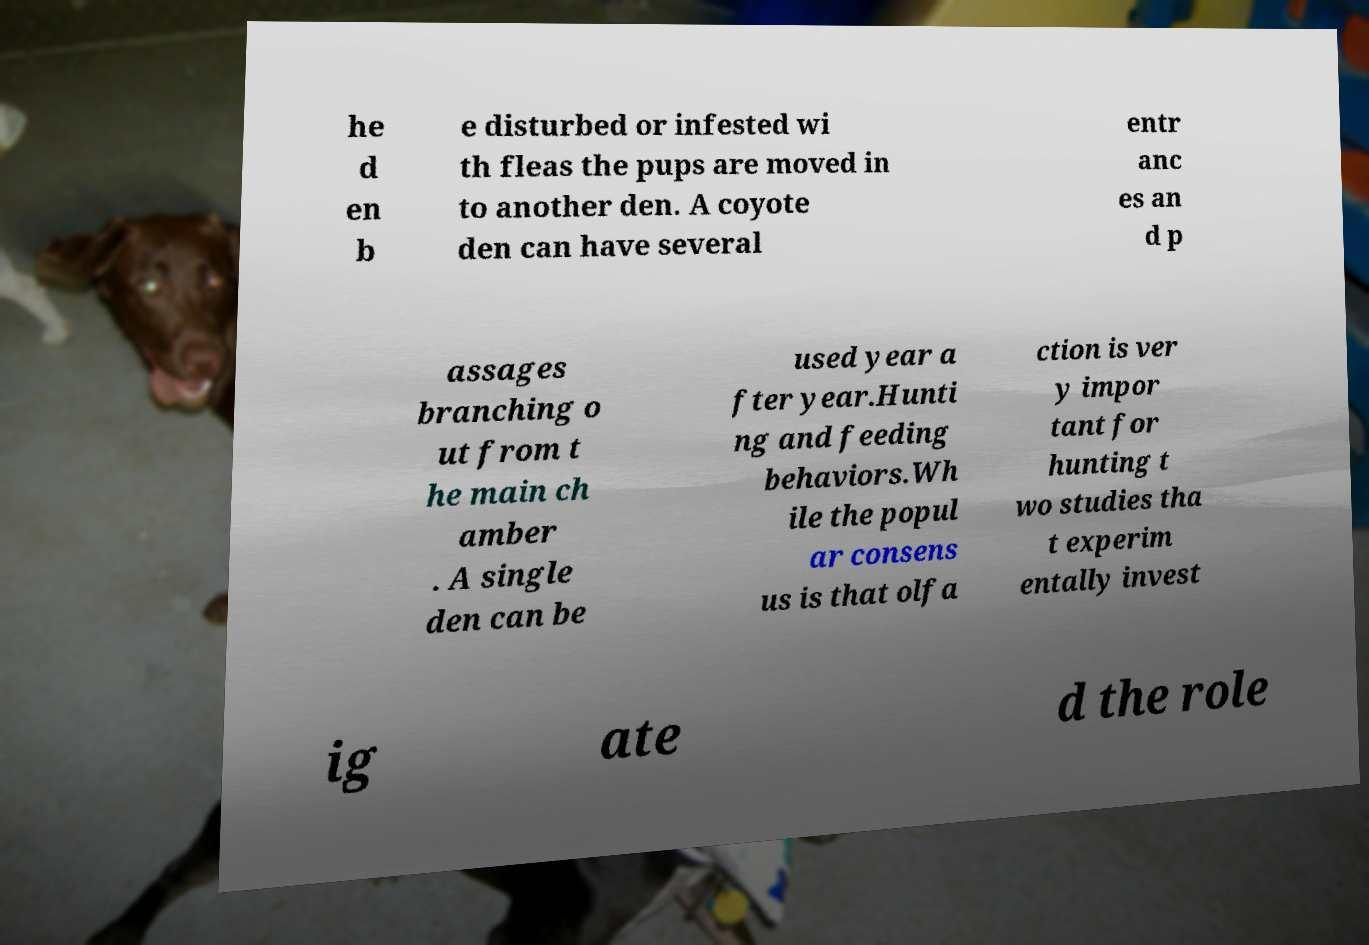Could you extract and type out the text from this image? he d en b e disturbed or infested wi th fleas the pups are moved in to another den. A coyote den can have several entr anc es an d p assages branching o ut from t he main ch amber . A single den can be used year a fter year.Hunti ng and feeding behaviors.Wh ile the popul ar consens us is that olfa ction is ver y impor tant for hunting t wo studies tha t experim entally invest ig ate d the role 